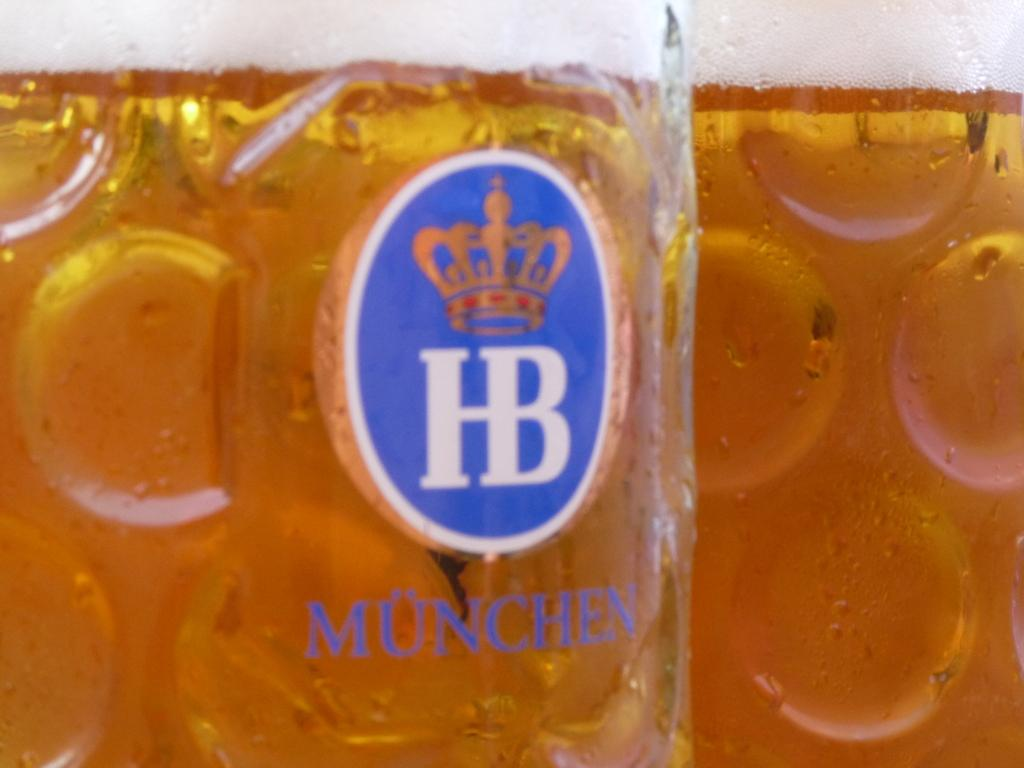<image>
Present a compact description of the photo's key features. A drinking glass with a kings crown on it and the letters HB. 